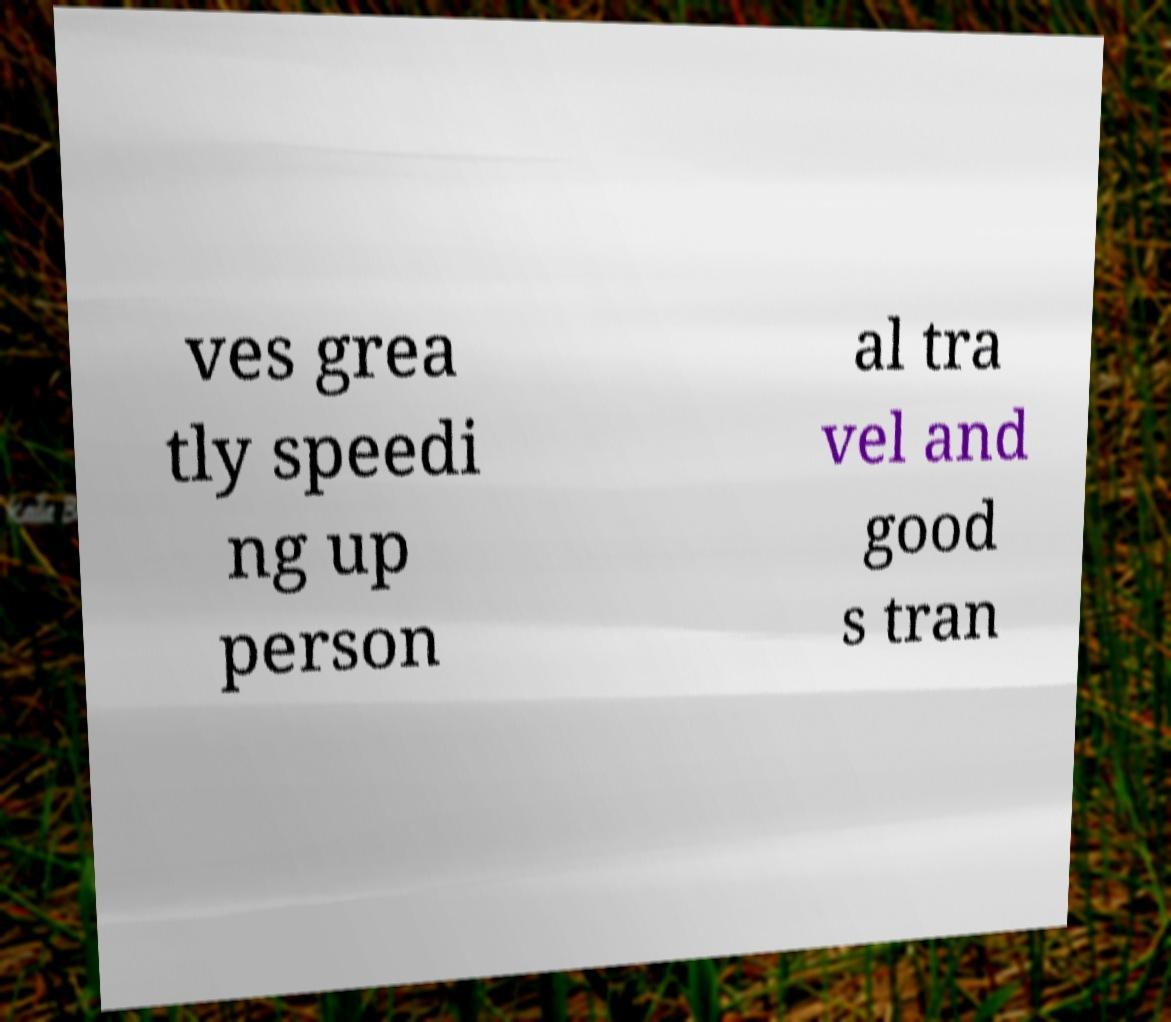There's text embedded in this image that I need extracted. Can you transcribe it verbatim? ves grea tly speedi ng up person al tra vel and good s tran 